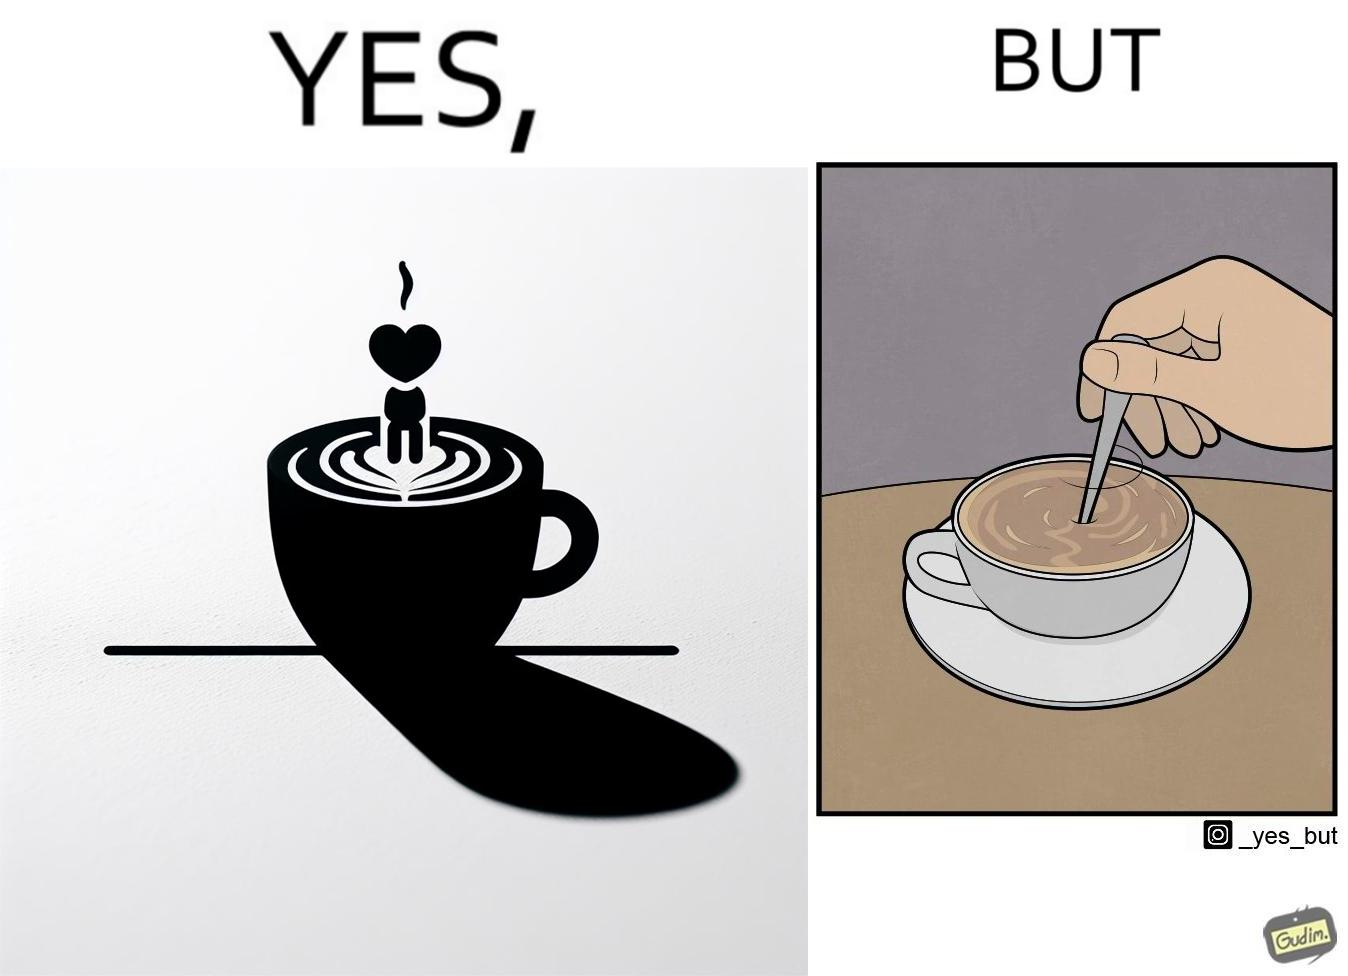Describe what you see in the left and right parts of this image. In the left part of the image: a cup of coffee with latte art on it In the right part of the image: a person stirring the coffee with spoon 